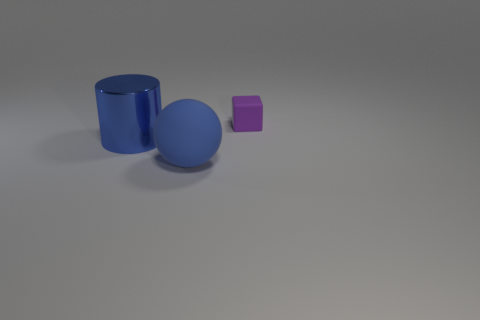Are there any other things that have the same size as the purple rubber block?
Your answer should be very brief. No. What shape is the thing that is behind the sphere and on the right side of the big metal object?
Provide a succinct answer. Cube. The thing that is on the right side of the big thing to the right of the big cylinder is what shape?
Offer a very short reply. Cube. Is the shape of the tiny object the same as the big metallic thing?
Offer a very short reply. No. What is the material of the other big thing that is the same color as the metallic thing?
Your answer should be very brief. Rubber. Does the small block have the same color as the metal cylinder?
Your answer should be very brief. No. There is a rubber object that is in front of the big thing behind the blue sphere; what number of tiny blocks are behind it?
Keep it short and to the point. 1. There is a object that is made of the same material as the ball; what shape is it?
Make the answer very short. Cube. What is the material of the large object in front of the large blue thing left of the large matte sphere to the right of the large metal thing?
Give a very brief answer. Rubber. How many objects are blue objects that are on the right side of the blue cylinder or red rubber objects?
Provide a succinct answer. 1. 